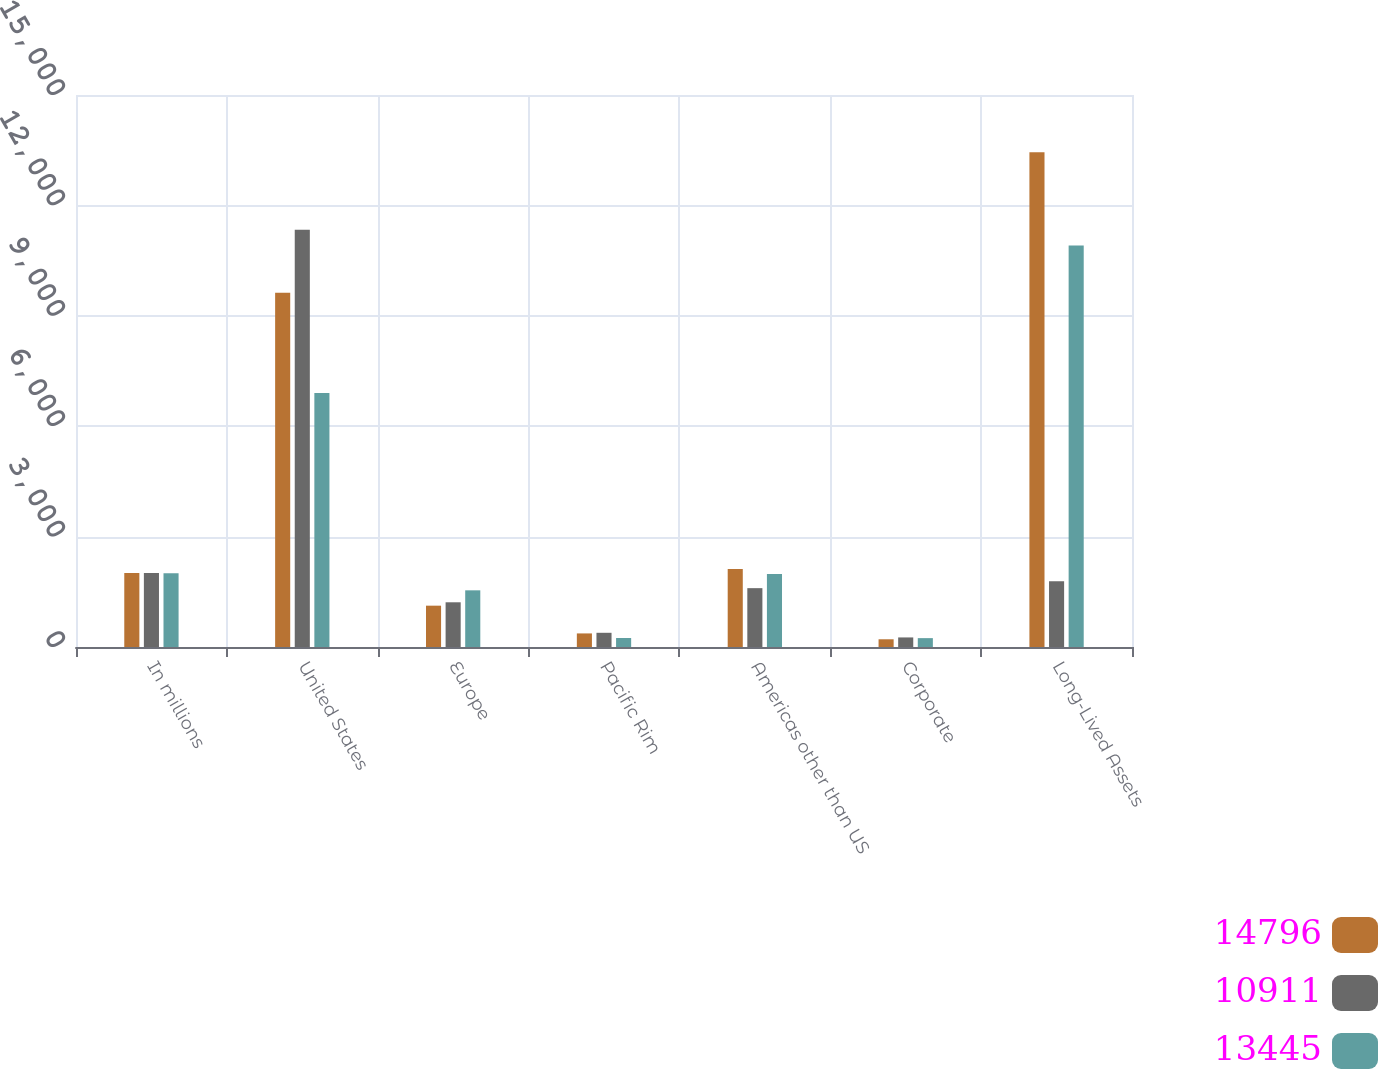<chart> <loc_0><loc_0><loc_500><loc_500><stacked_bar_chart><ecel><fcel>In millions<fcel>United States<fcel>Europe<fcel>Pacific Rim<fcel>Americas other than US<fcel>Corporate<fcel>Long-Lived Assets<nl><fcel>14796<fcel>2009<fcel>9626<fcel>1123<fcel>369<fcel>2117<fcel>210<fcel>13445<nl><fcel>10911<fcel>2008<fcel>11336<fcel>1215<fcel>386<fcel>1599<fcel>260<fcel>1790<nl><fcel>13445<fcel>2007<fcel>6905<fcel>1540<fcel>244<fcel>1981<fcel>241<fcel>10911<nl></chart> 